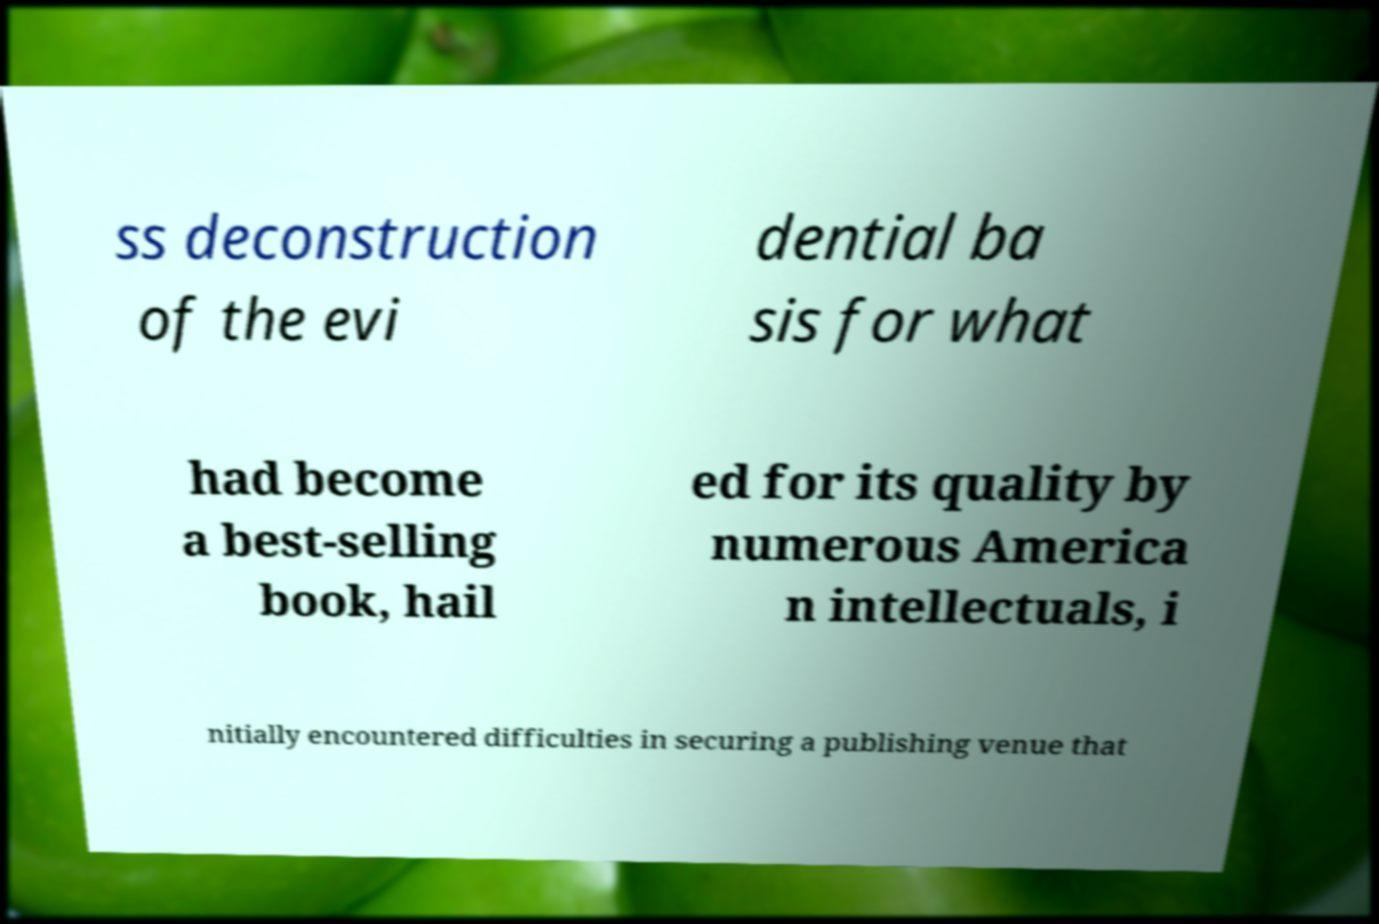Can you accurately transcribe the text from the provided image for me? ss deconstruction of the evi dential ba sis for what had become a best-selling book, hail ed for its quality by numerous America n intellectuals, i nitially encountered difficulties in securing a publishing venue that 